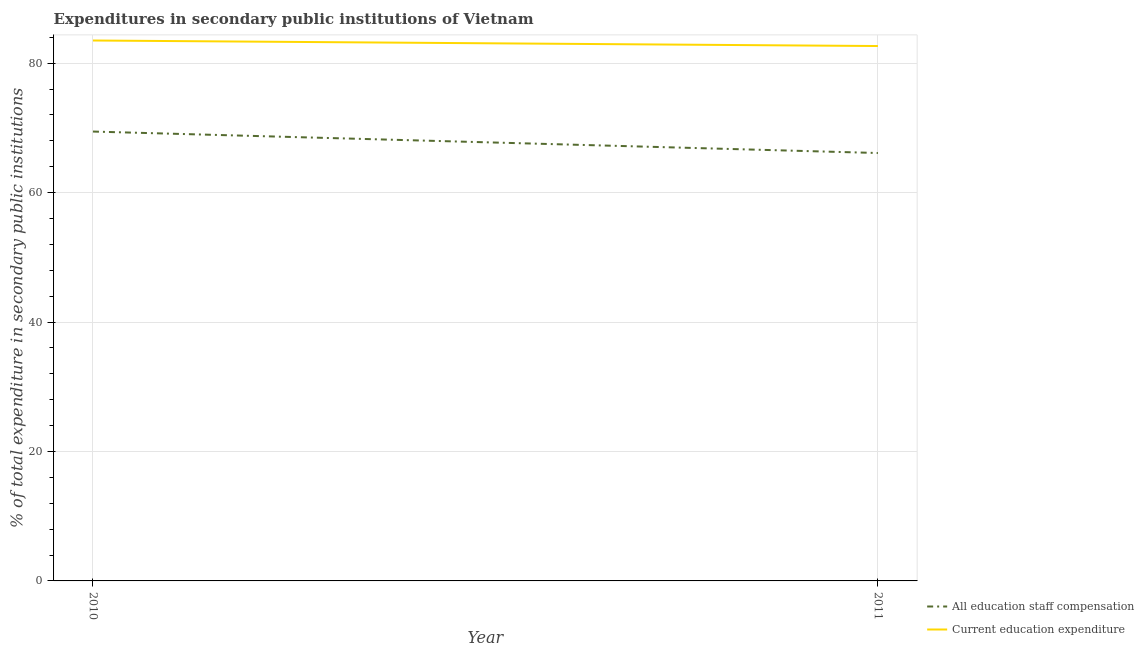Does the line corresponding to expenditure in education intersect with the line corresponding to expenditure in staff compensation?
Keep it short and to the point. No. Is the number of lines equal to the number of legend labels?
Offer a very short reply. Yes. What is the expenditure in education in 2011?
Your answer should be very brief. 82.65. Across all years, what is the maximum expenditure in education?
Make the answer very short. 83.51. Across all years, what is the minimum expenditure in education?
Ensure brevity in your answer.  82.65. In which year was the expenditure in staff compensation minimum?
Provide a succinct answer. 2011. What is the total expenditure in education in the graph?
Provide a succinct answer. 166.16. What is the difference between the expenditure in staff compensation in 2010 and that in 2011?
Make the answer very short. 3.32. What is the difference between the expenditure in education in 2010 and the expenditure in staff compensation in 2011?
Offer a very short reply. 17.39. What is the average expenditure in staff compensation per year?
Your response must be concise. 67.78. In the year 2010, what is the difference between the expenditure in staff compensation and expenditure in education?
Give a very brief answer. -14.07. In how many years, is the expenditure in staff compensation greater than 68 %?
Ensure brevity in your answer.  1. What is the ratio of the expenditure in education in 2010 to that in 2011?
Give a very brief answer. 1.01. In how many years, is the expenditure in education greater than the average expenditure in education taken over all years?
Keep it short and to the point. 1. Does the expenditure in education monotonically increase over the years?
Keep it short and to the point. No. What is the difference between two consecutive major ticks on the Y-axis?
Make the answer very short. 20. Does the graph contain grids?
Provide a succinct answer. Yes. How many legend labels are there?
Keep it short and to the point. 2. What is the title of the graph?
Make the answer very short. Expenditures in secondary public institutions of Vietnam. What is the label or title of the Y-axis?
Offer a very short reply. % of total expenditure in secondary public institutions. What is the % of total expenditure in secondary public institutions in All education staff compensation in 2010?
Your response must be concise. 69.44. What is the % of total expenditure in secondary public institutions in Current education expenditure in 2010?
Your answer should be very brief. 83.51. What is the % of total expenditure in secondary public institutions of All education staff compensation in 2011?
Ensure brevity in your answer.  66.12. What is the % of total expenditure in secondary public institutions in Current education expenditure in 2011?
Your answer should be very brief. 82.65. Across all years, what is the maximum % of total expenditure in secondary public institutions of All education staff compensation?
Provide a short and direct response. 69.44. Across all years, what is the maximum % of total expenditure in secondary public institutions of Current education expenditure?
Keep it short and to the point. 83.51. Across all years, what is the minimum % of total expenditure in secondary public institutions of All education staff compensation?
Offer a terse response. 66.12. Across all years, what is the minimum % of total expenditure in secondary public institutions of Current education expenditure?
Offer a very short reply. 82.65. What is the total % of total expenditure in secondary public institutions of All education staff compensation in the graph?
Give a very brief answer. 135.56. What is the total % of total expenditure in secondary public institutions of Current education expenditure in the graph?
Offer a very short reply. 166.16. What is the difference between the % of total expenditure in secondary public institutions of All education staff compensation in 2010 and that in 2011?
Your response must be concise. 3.32. What is the difference between the % of total expenditure in secondary public institutions of Current education expenditure in 2010 and that in 2011?
Give a very brief answer. 0.86. What is the difference between the % of total expenditure in secondary public institutions in All education staff compensation in 2010 and the % of total expenditure in secondary public institutions in Current education expenditure in 2011?
Your answer should be compact. -13.21. What is the average % of total expenditure in secondary public institutions of All education staff compensation per year?
Keep it short and to the point. 67.78. What is the average % of total expenditure in secondary public institutions of Current education expenditure per year?
Make the answer very short. 83.08. In the year 2010, what is the difference between the % of total expenditure in secondary public institutions in All education staff compensation and % of total expenditure in secondary public institutions in Current education expenditure?
Provide a succinct answer. -14.07. In the year 2011, what is the difference between the % of total expenditure in secondary public institutions of All education staff compensation and % of total expenditure in secondary public institutions of Current education expenditure?
Ensure brevity in your answer.  -16.53. What is the ratio of the % of total expenditure in secondary public institutions of All education staff compensation in 2010 to that in 2011?
Your answer should be compact. 1.05. What is the ratio of the % of total expenditure in secondary public institutions of Current education expenditure in 2010 to that in 2011?
Your response must be concise. 1.01. What is the difference between the highest and the second highest % of total expenditure in secondary public institutions in All education staff compensation?
Offer a terse response. 3.32. What is the difference between the highest and the second highest % of total expenditure in secondary public institutions of Current education expenditure?
Make the answer very short. 0.86. What is the difference between the highest and the lowest % of total expenditure in secondary public institutions in All education staff compensation?
Provide a short and direct response. 3.32. What is the difference between the highest and the lowest % of total expenditure in secondary public institutions in Current education expenditure?
Keep it short and to the point. 0.86. 